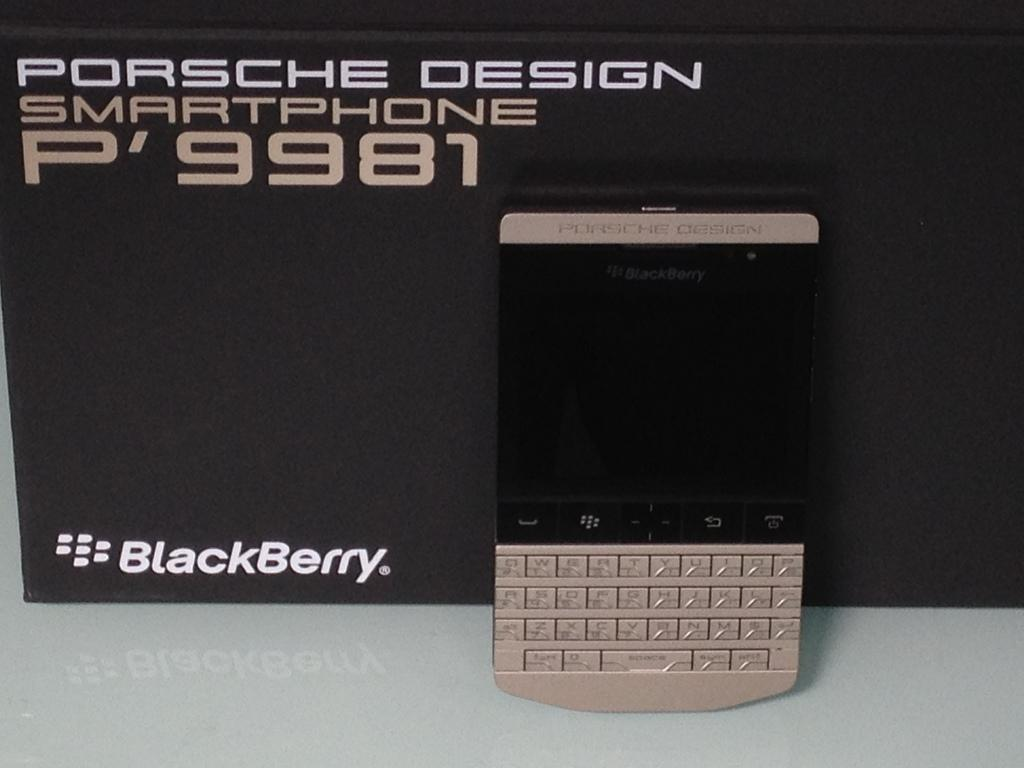<image>
Describe the image concisely. A new Porsche Design, Blackberry cellphone leaning up against the box it comes in. 